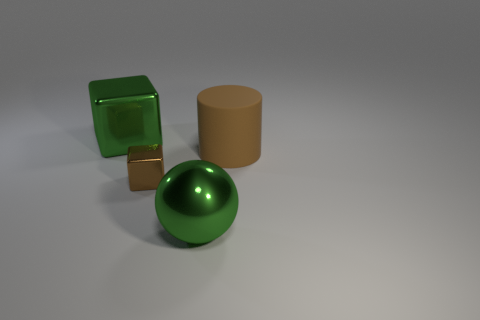Add 2 large metal spheres. How many objects exist? 6 Subtract all cylinders. How many objects are left? 3 Add 1 big green shiny balls. How many big green shiny balls are left? 2 Add 4 large brown matte objects. How many large brown matte objects exist? 5 Subtract 0 cyan spheres. How many objects are left? 4 Subtract all small blocks. Subtract all big green metallic objects. How many objects are left? 1 